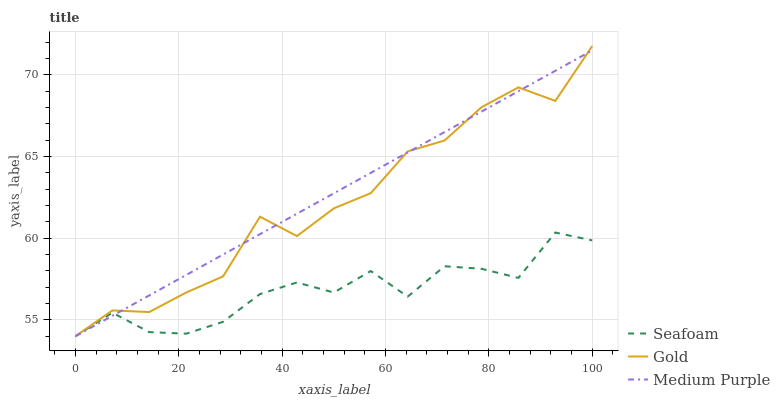Does Seafoam have the minimum area under the curve?
Answer yes or no. Yes. Does Medium Purple have the maximum area under the curve?
Answer yes or no. Yes. Does Gold have the minimum area under the curve?
Answer yes or no. No. Does Gold have the maximum area under the curve?
Answer yes or no. No. Is Medium Purple the smoothest?
Answer yes or no. Yes. Is Gold the roughest?
Answer yes or no. Yes. Is Seafoam the smoothest?
Answer yes or no. No. Is Seafoam the roughest?
Answer yes or no. No. Does Medium Purple have the lowest value?
Answer yes or no. Yes. Does Gold have the highest value?
Answer yes or no. Yes. Does Seafoam have the highest value?
Answer yes or no. No. Does Medium Purple intersect Seafoam?
Answer yes or no. Yes. Is Medium Purple less than Seafoam?
Answer yes or no. No. Is Medium Purple greater than Seafoam?
Answer yes or no. No. 